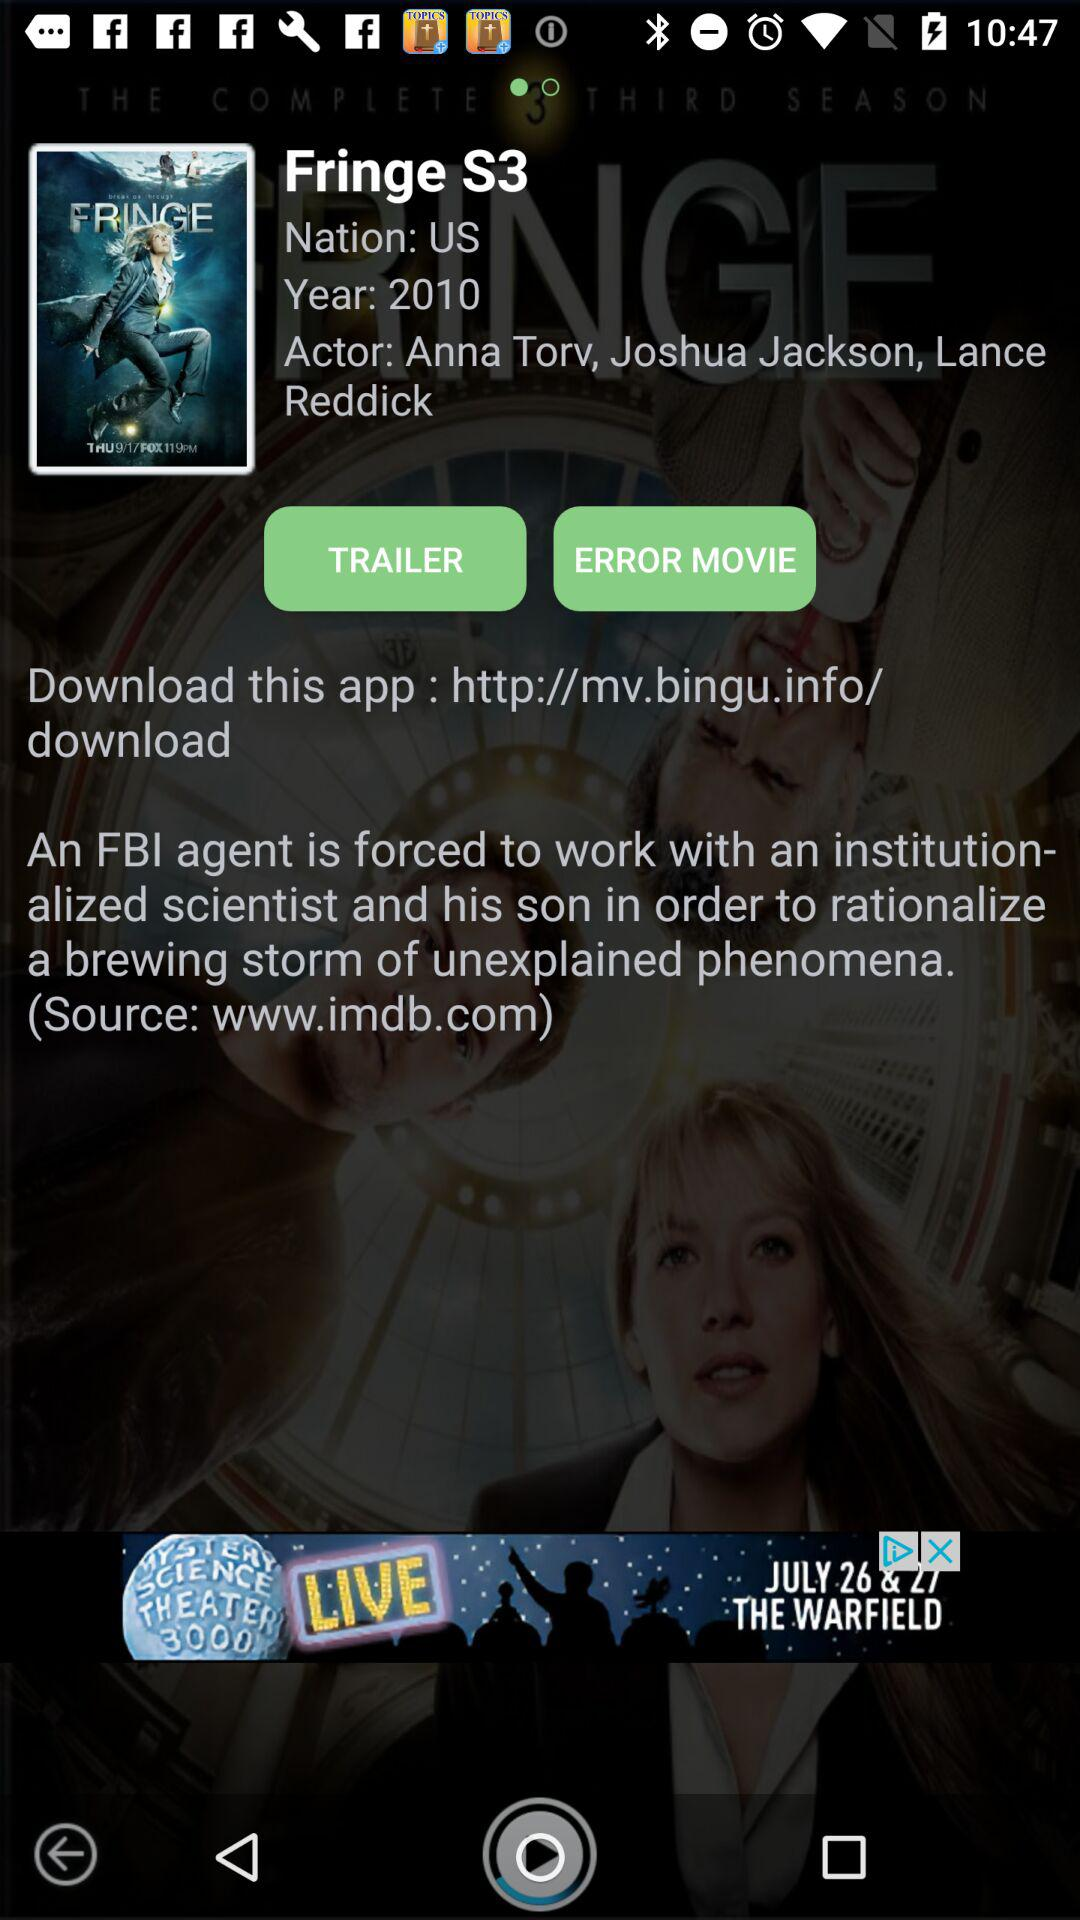What are the names of the actors? The names of the actors are Anna Torv, Joshua Jackson and Lance Reddick. 